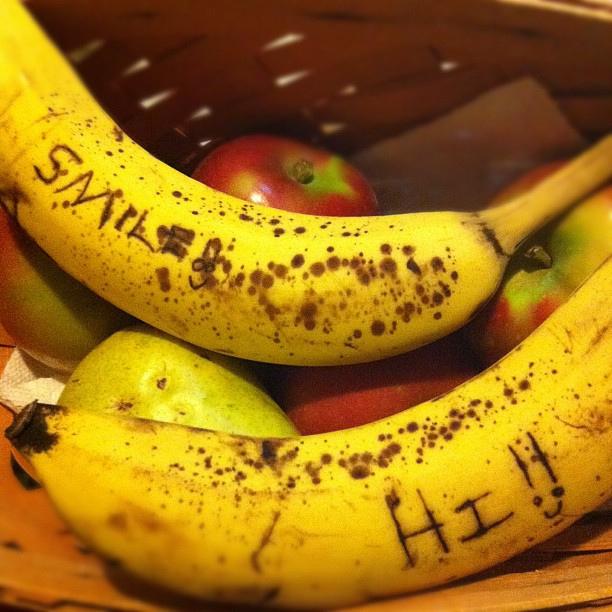What kind of fruit is written on?
Short answer required. Banana. What is written on the bananas?
Answer briefly. Smile hi. Does that spoil the fruit to badly to be eaten?
Give a very brief answer. No. 